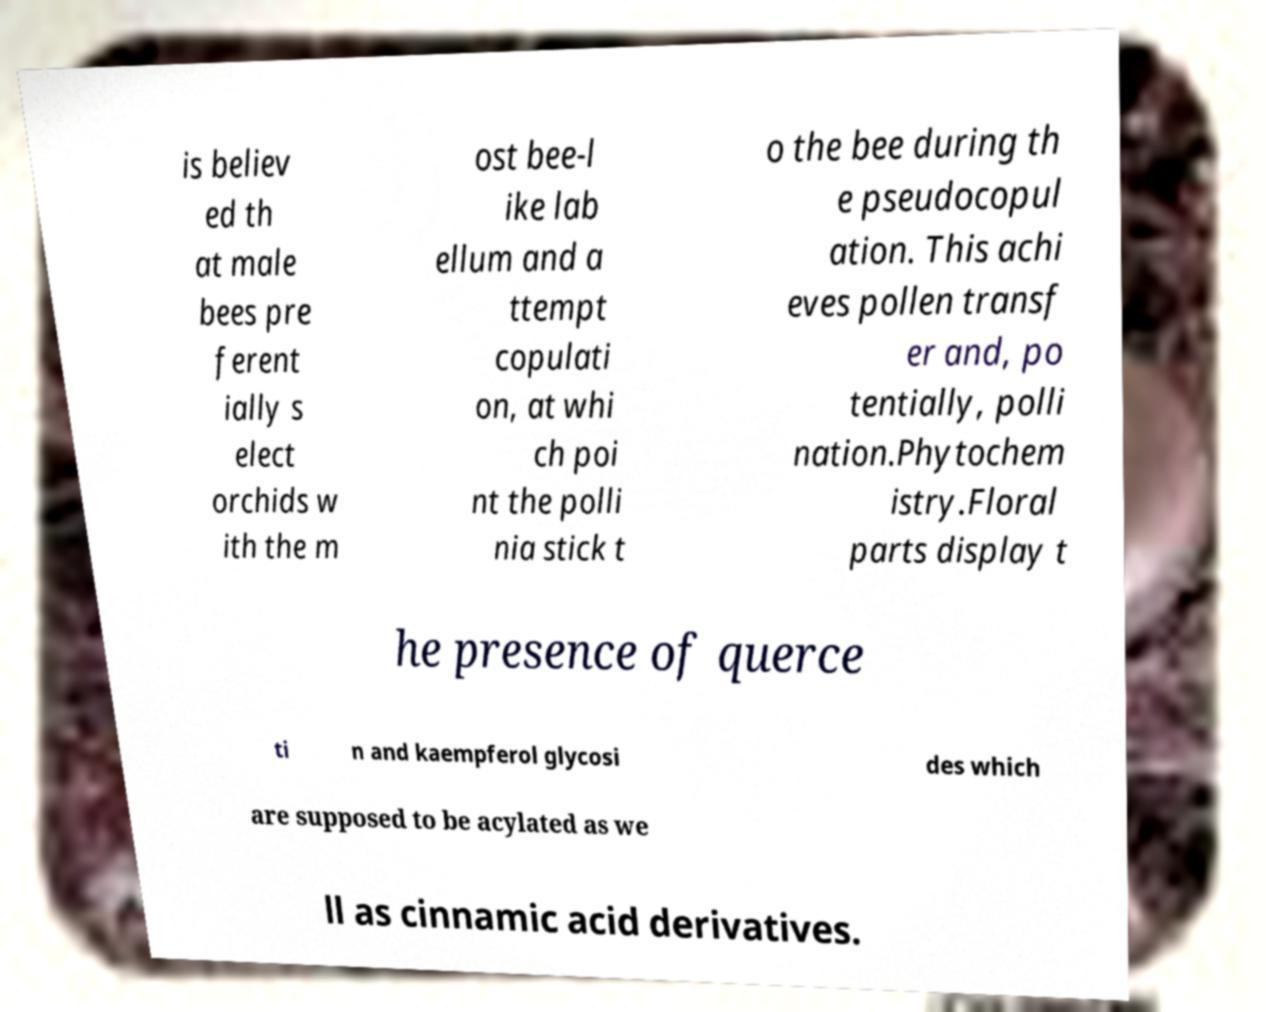For documentation purposes, I need the text within this image transcribed. Could you provide that? is believ ed th at male bees pre ferent ially s elect orchids w ith the m ost bee-l ike lab ellum and a ttempt copulati on, at whi ch poi nt the polli nia stick t o the bee during th e pseudocopul ation. This achi eves pollen transf er and, po tentially, polli nation.Phytochem istry.Floral parts display t he presence of querce ti n and kaempferol glycosi des which are supposed to be acylated as we ll as cinnamic acid derivatives. 